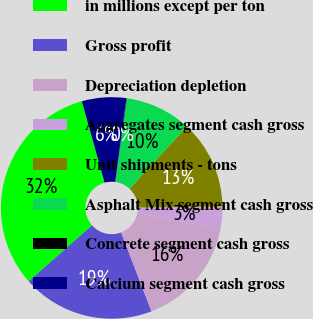Convert chart to OTSL. <chart><loc_0><loc_0><loc_500><loc_500><pie_chart><fcel>in millions except per ton<fcel>Gross profit<fcel>Depreciation depletion<fcel>Aggregates segment cash gross<fcel>Unit shipments - tons<fcel>Asphalt Mix segment cash gross<fcel>Concrete segment cash gross<fcel>Calcium segment cash gross<nl><fcel>32.18%<fcel>19.33%<fcel>16.11%<fcel>3.26%<fcel>12.9%<fcel>9.69%<fcel>0.05%<fcel>6.48%<nl></chart> 